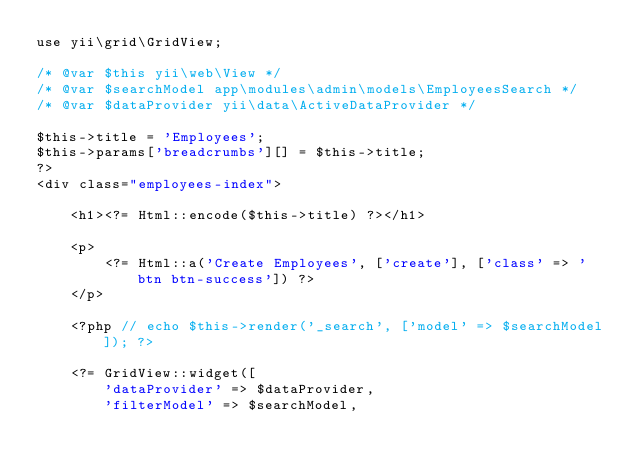Convert code to text. <code><loc_0><loc_0><loc_500><loc_500><_PHP_>use yii\grid\GridView;

/* @var $this yii\web\View */
/* @var $searchModel app\modules\admin\models\EmployeesSearch */
/* @var $dataProvider yii\data\ActiveDataProvider */

$this->title = 'Employees';
$this->params['breadcrumbs'][] = $this->title;
?>
<div class="employees-index">

    <h1><?= Html::encode($this->title) ?></h1>

    <p>
        <?= Html::a('Create Employees', ['create'], ['class' => 'btn btn-success']) ?>
    </p>

    <?php // echo $this->render('_search', ['model' => $searchModel]); ?>

    <?= GridView::widget([
        'dataProvider' => $dataProvider,
        'filterModel' => $searchModel,</code> 